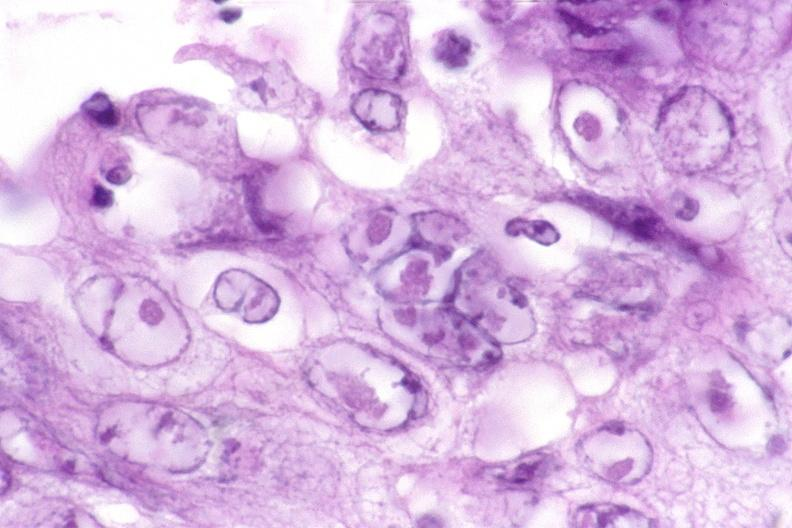does this image show esophagus, herpes ulcers with inclusion bodies?
Answer the question using a single word or phrase. Yes 